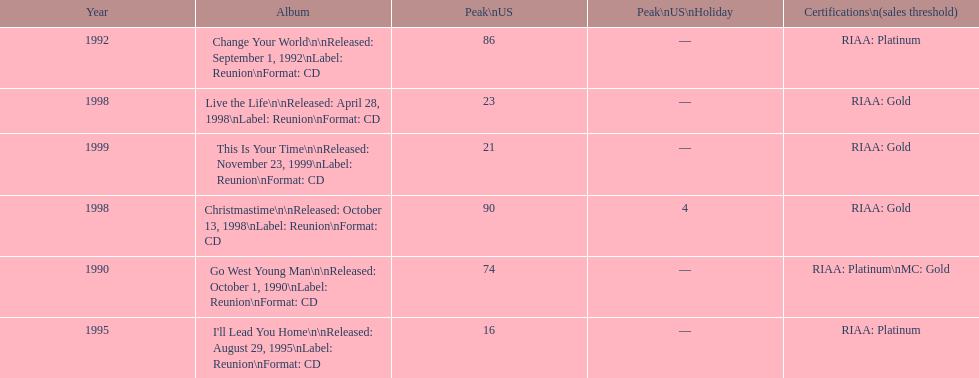How many album entries are there? 6. 